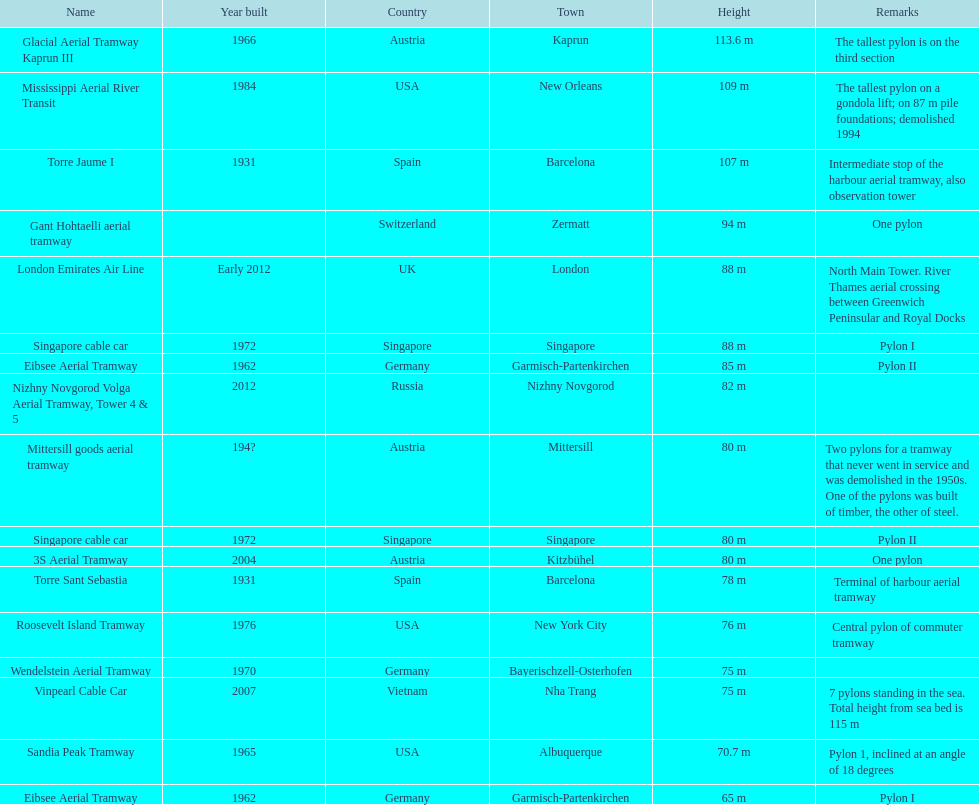What year was the last pylon in germany built? 1970. 